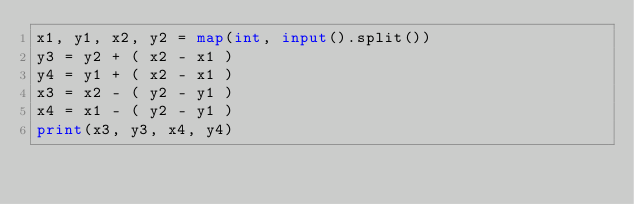Convert code to text. <code><loc_0><loc_0><loc_500><loc_500><_Python_>x1, y1, x2, y2 = map(int, input().split())
y3 = y2 + ( x2 - x1 )
y4 = y1 + ( x2 - x1 )
x3 = x2 - ( y2 - y1 )
x4 = x1 - ( y2 - y1 )
print(x3, y3, x4, y4)
</code> 